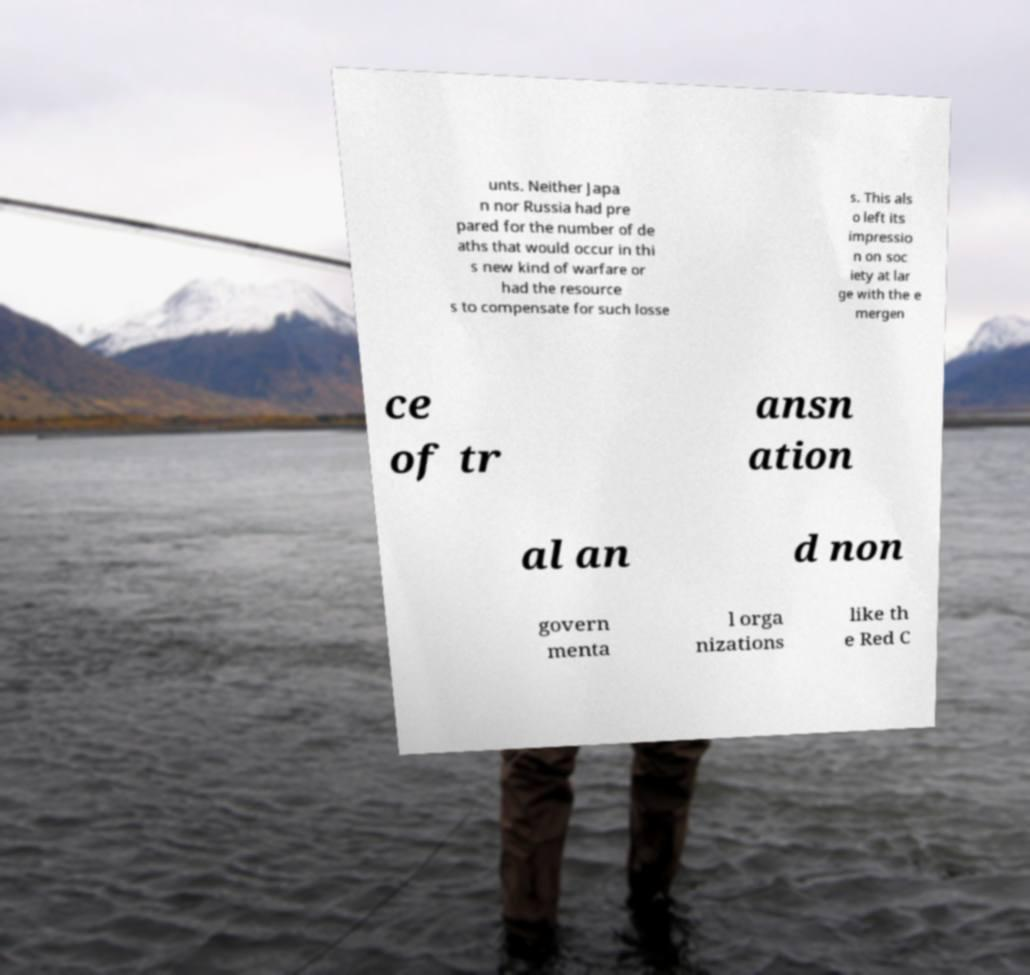There's text embedded in this image that I need extracted. Can you transcribe it verbatim? unts. Neither Japa n nor Russia had pre pared for the number of de aths that would occur in thi s new kind of warfare or had the resource s to compensate for such losse s. This als o left its impressio n on soc iety at lar ge with the e mergen ce of tr ansn ation al an d non govern menta l orga nizations like th e Red C 